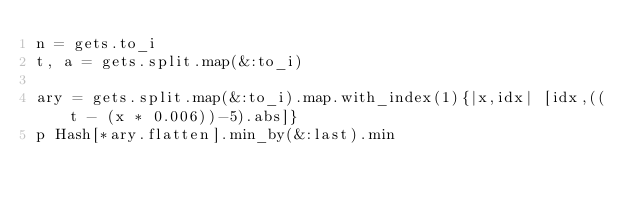Convert code to text. <code><loc_0><loc_0><loc_500><loc_500><_Ruby_>n = gets.to_i
t, a = gets.split.map(&:to_i)

ary = gets.split.map(&:to_i).map.with_index(1){|x,idx| [idx,((t - (x * 0.006))-5).abs]}
p Hash[*ary.flatten].min_by(&:last).min</code> 